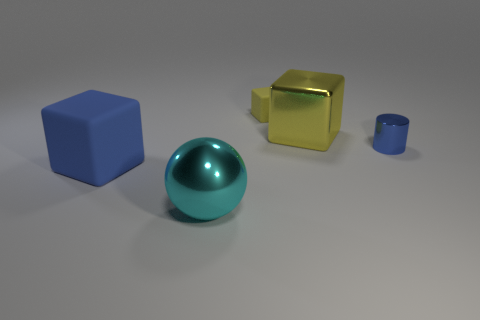Is there anything else that is the same color as the small metallic thing?
Provide a succinct answer. Yes. There is a big blue thing that is made of the same material as the small block; what is its shape?
Give a very brief answer. Cube. What is the color of the large block behind the blue object that is on the right side of the blue object that is to the left of the blue metallic thing?
Give a very brief answer. Yellow. Are there the same number of tiny yellow rubber objects that are in front of the large metallic block and big cyan objects?
Keep it short and to the point. No. Is there anything else that is made of the same material as the large blue block?
Ensure brevity in your answer.  Yes. There is a big metal block; is it the same color as the big block in front of the tiny cylinder?
Provide a short and direct response. No. There is a big metallic thing to the right of the big metallic object that is on the left side of the tiny yellow rubber cube; is there a tiny shiny cylinder that is left of it?
Provide a succinct answer. No. Are there fewer tiny yellow cubes that are in front of the blue rubber cube than large gray metal blocks?
Offer a terse response. No. What number of other objects are there of the same shape as the large cyan metal object?
Offer a very short reply. 0. How many things are large cubes to the left of the cyan object or big objects that are on the right side of the cyan ball?
Your answer should be compact. 2. 